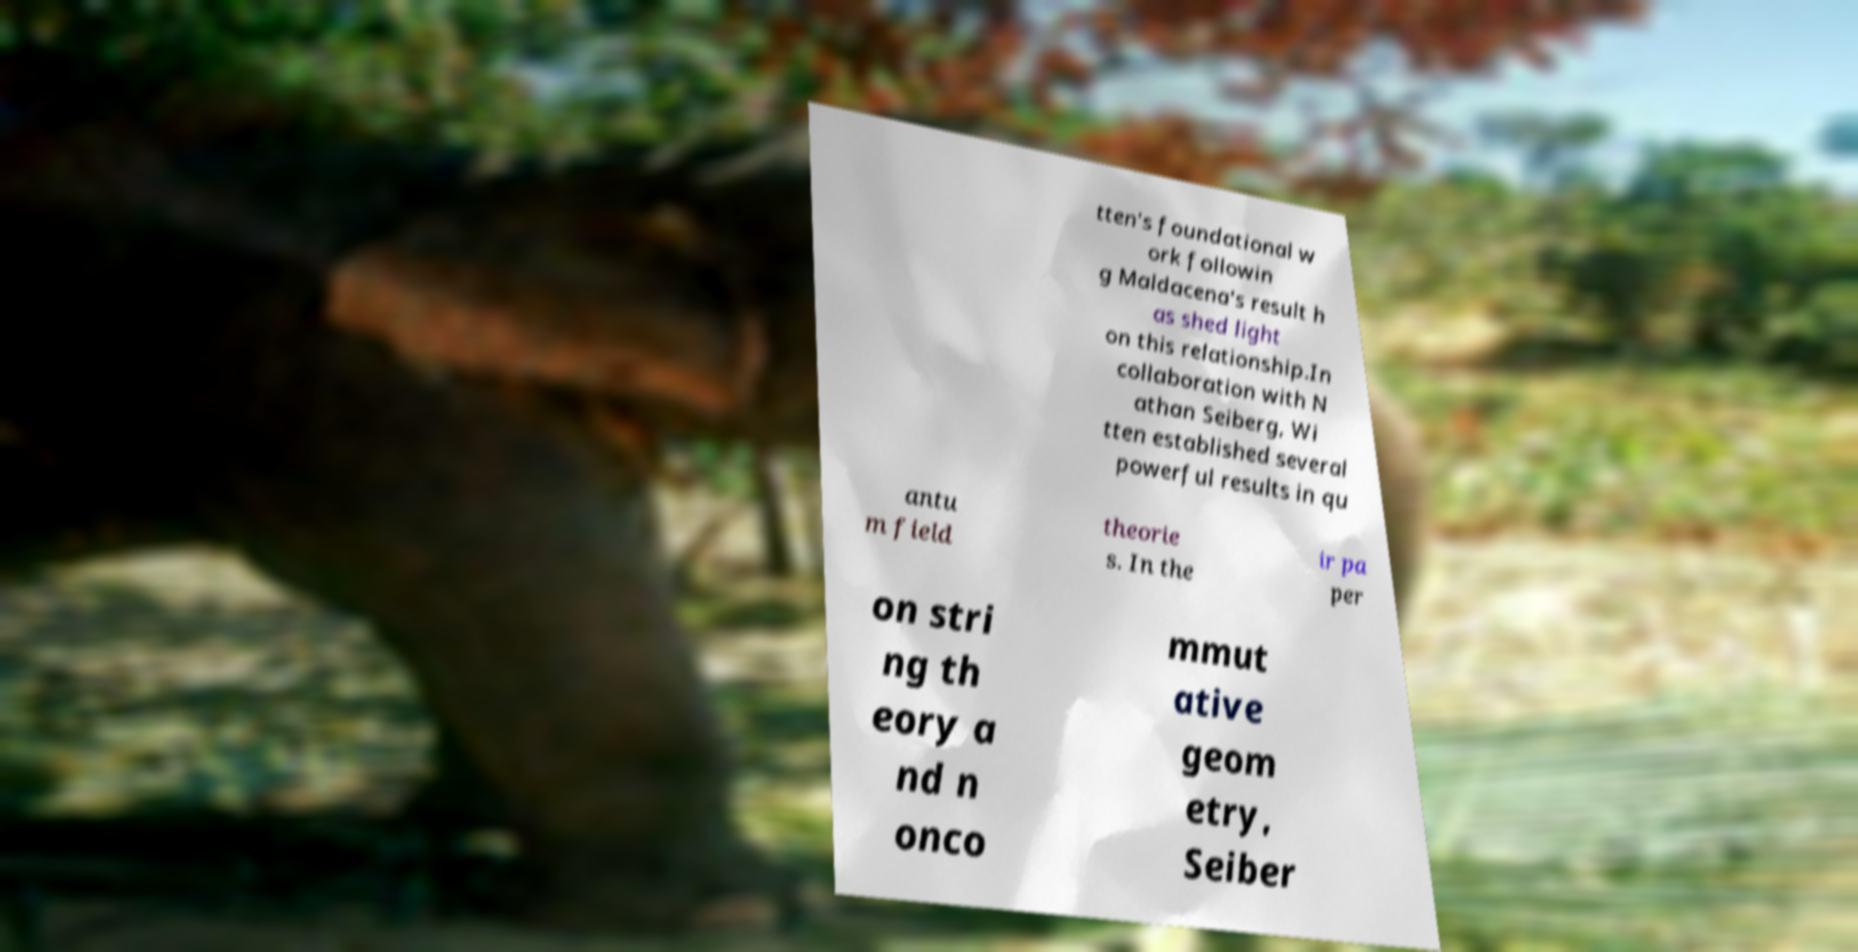Please read and relay the text visible in this image. What does it say? tten's foundational w ork followin g Maldacena's result h as shed light on this relationship.In collaboration with N athan Seiberg, Wi tten established several powerful results in qu antu m field theorie s. In the ir pa per on stri ng th eory a nd n onco mmut ative geom etry, Seiber 